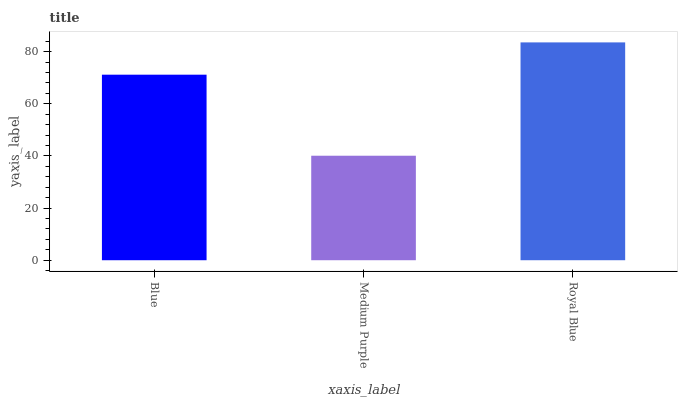Is Medium Purple the minimum?
Answer yes or no. Yes. Is Royal Blue the maximum?
Answer yes or no. Yes. Is Royal Blue the minimum?
Answer yes or no. No. Is Medium Purple the maximum?
Answer yes or no. No. Is Royal Blue greater than Medium Purple?
Answer yes or no. Yes. Is Medium Purple less than Royal Blue?
Answer yes or no. Yes. Is Medium Purple greater than Royal Blue?
Answer yes or no. No. Is Royal Blue less than Medium Purple?
Answer yes or no. No. Is Blue the high median?
Answer yes or no. Yes. Is Blue the low median?
Answer yes or no. Yes. Is Medium Purple the high median?
Answer yes or no. No. Is Medium Purple the low median?
Answer yes or no. No. 